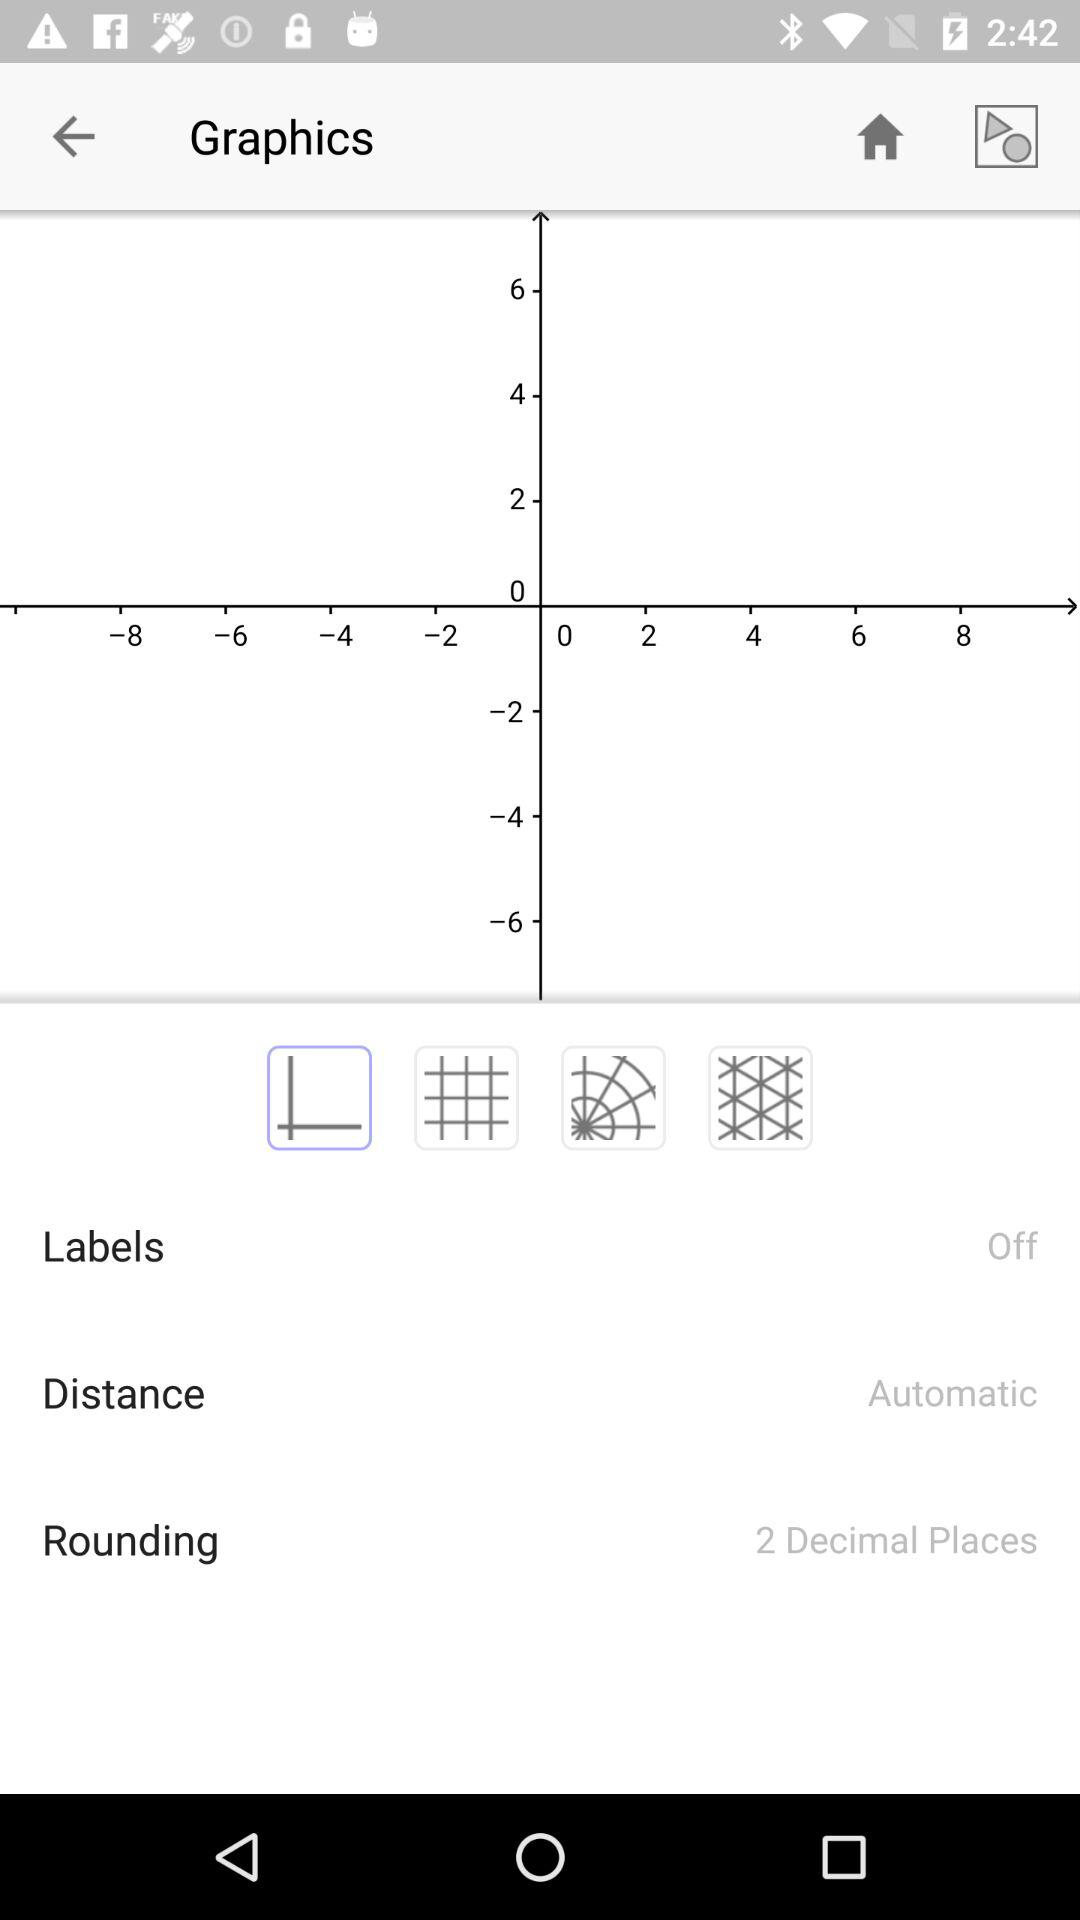How many decimals should I round a number to? Rounding to two decimal places is appropriate. 